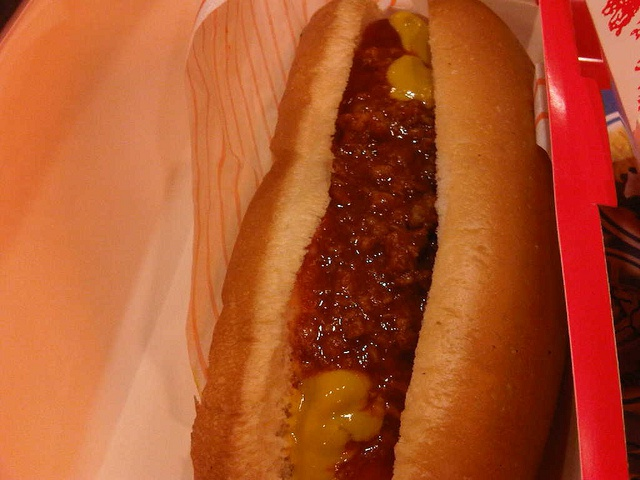Describe the objects in this image and their specific colors. I can see hot dog in black, brown, maroon, and orange tones and sandwich in black, brown, maroon, and orange tones in this image. 